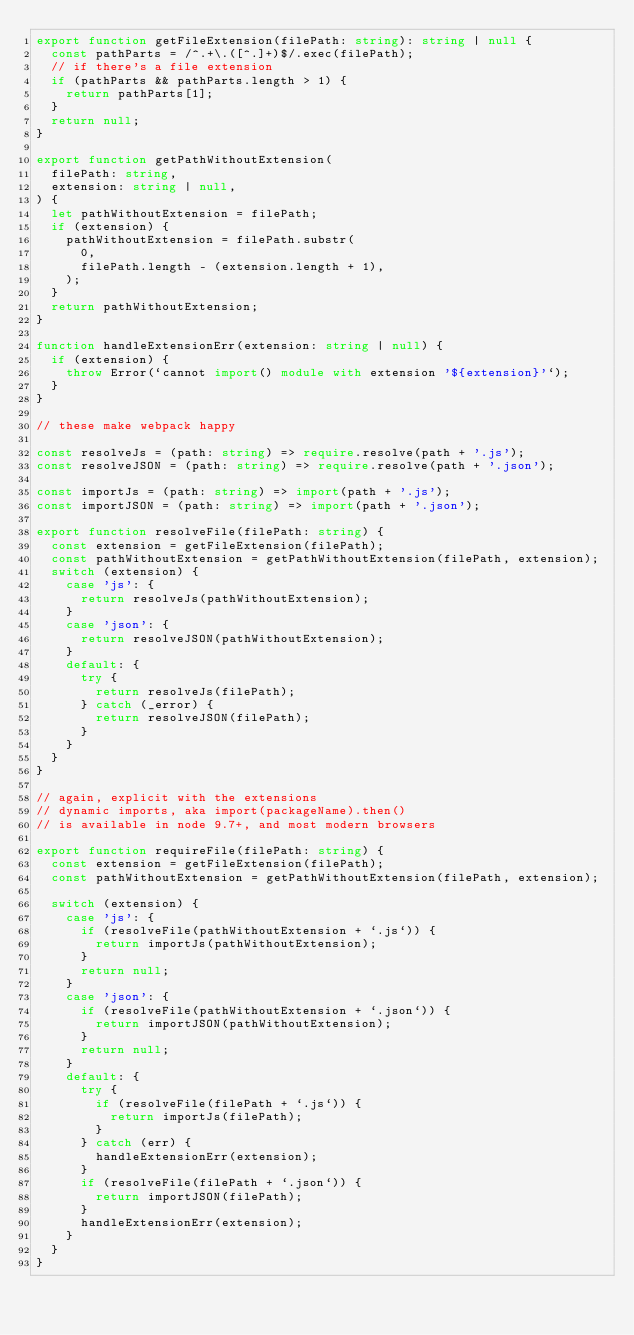<code> <loc_0><loc_0><loc_500><loc_500><_TypeScript_>export function getFileExtension(filePath: string): string | null {
  const pathParts = /^.+\.([^.]+)$/.exec(filePath);
  // if there's a file extension
  if (pathParts && pathParts.length > 1) {
    return pathParts[1];
  }
  return null;
}

export function getPathWithoutExtension(
  filePath: string,
  extension: string | null,
) {
  let pathWithoutExtension = filePath;
  if (extension) {
    pathWithoutExtension = filePath.substr(
      0,
      filePath.length - (extension.length + 1),
    );
  }
  return pathWithoutExtension;
}

function handleExtensionErr(extension: string | null) {
  if (extension) {
    throw Error(`cannot import() module with extension '${extension}'`);
  }
}

// these make webpack happy

const resolveJs = (path: string) => require.resolve(path + '.js');
const resolveJSON = (path: string) => require.resolve(path + '.json');

const importJs = (path: string) => import(path + '.js');
const importJSON = (path: string) => import(path + '.json');

export function resolveFile(filePath: string) {
  const extension = getFileExtension(filePath);
  const pathWithoutExtension = getPathWithoutExtension(filePath, extension);
  switch (extension) {
    case 'js': {
      return resolveJs(pathWithoutExtension);
    }
    case 'json': {
      return resolveJSON(pathWithoutExtension);
    }
    default: {
      try {
        return resolveJs(filePath);
      } catch (_error) {
        return resolveJSON(filePath);
      }
    }
  }
}

// again, explicit with the extensions
// dynamic imports, aka import(packageName).then()
// is available in node 9.7+, and most modern browsers

export function requireFile(filePath: string) {
  const extension = getFileExtension(filePath);
  const pathWithoutExtension = getPathWithoutExtension(filePath, extension);

  switch (extension) {
    case 'js': {
      if (resolveFile(pathWithoutExtension + `.js`)) {
        return importJs(pathWithoutExtension);
      }
      return null;
    }
    case 'json': {
      if (resolveFile(pathWithoutExtension + `.json`)) {
        return importJSON(pathWithoutExtension);
      }
      return null;
    }
    default: {
      try {
        if (resolveFile(filePath + `.js`)) {
          return importJs(filePath);
        }
      } catch (err) {
        handleExtensionErr(extension);
      }
      if (resolveFile(filePath + `.json`)) {
        return importJSON(filePath);
      }
      handleExtensionErr(extension);
    }
  }
}
</code> 